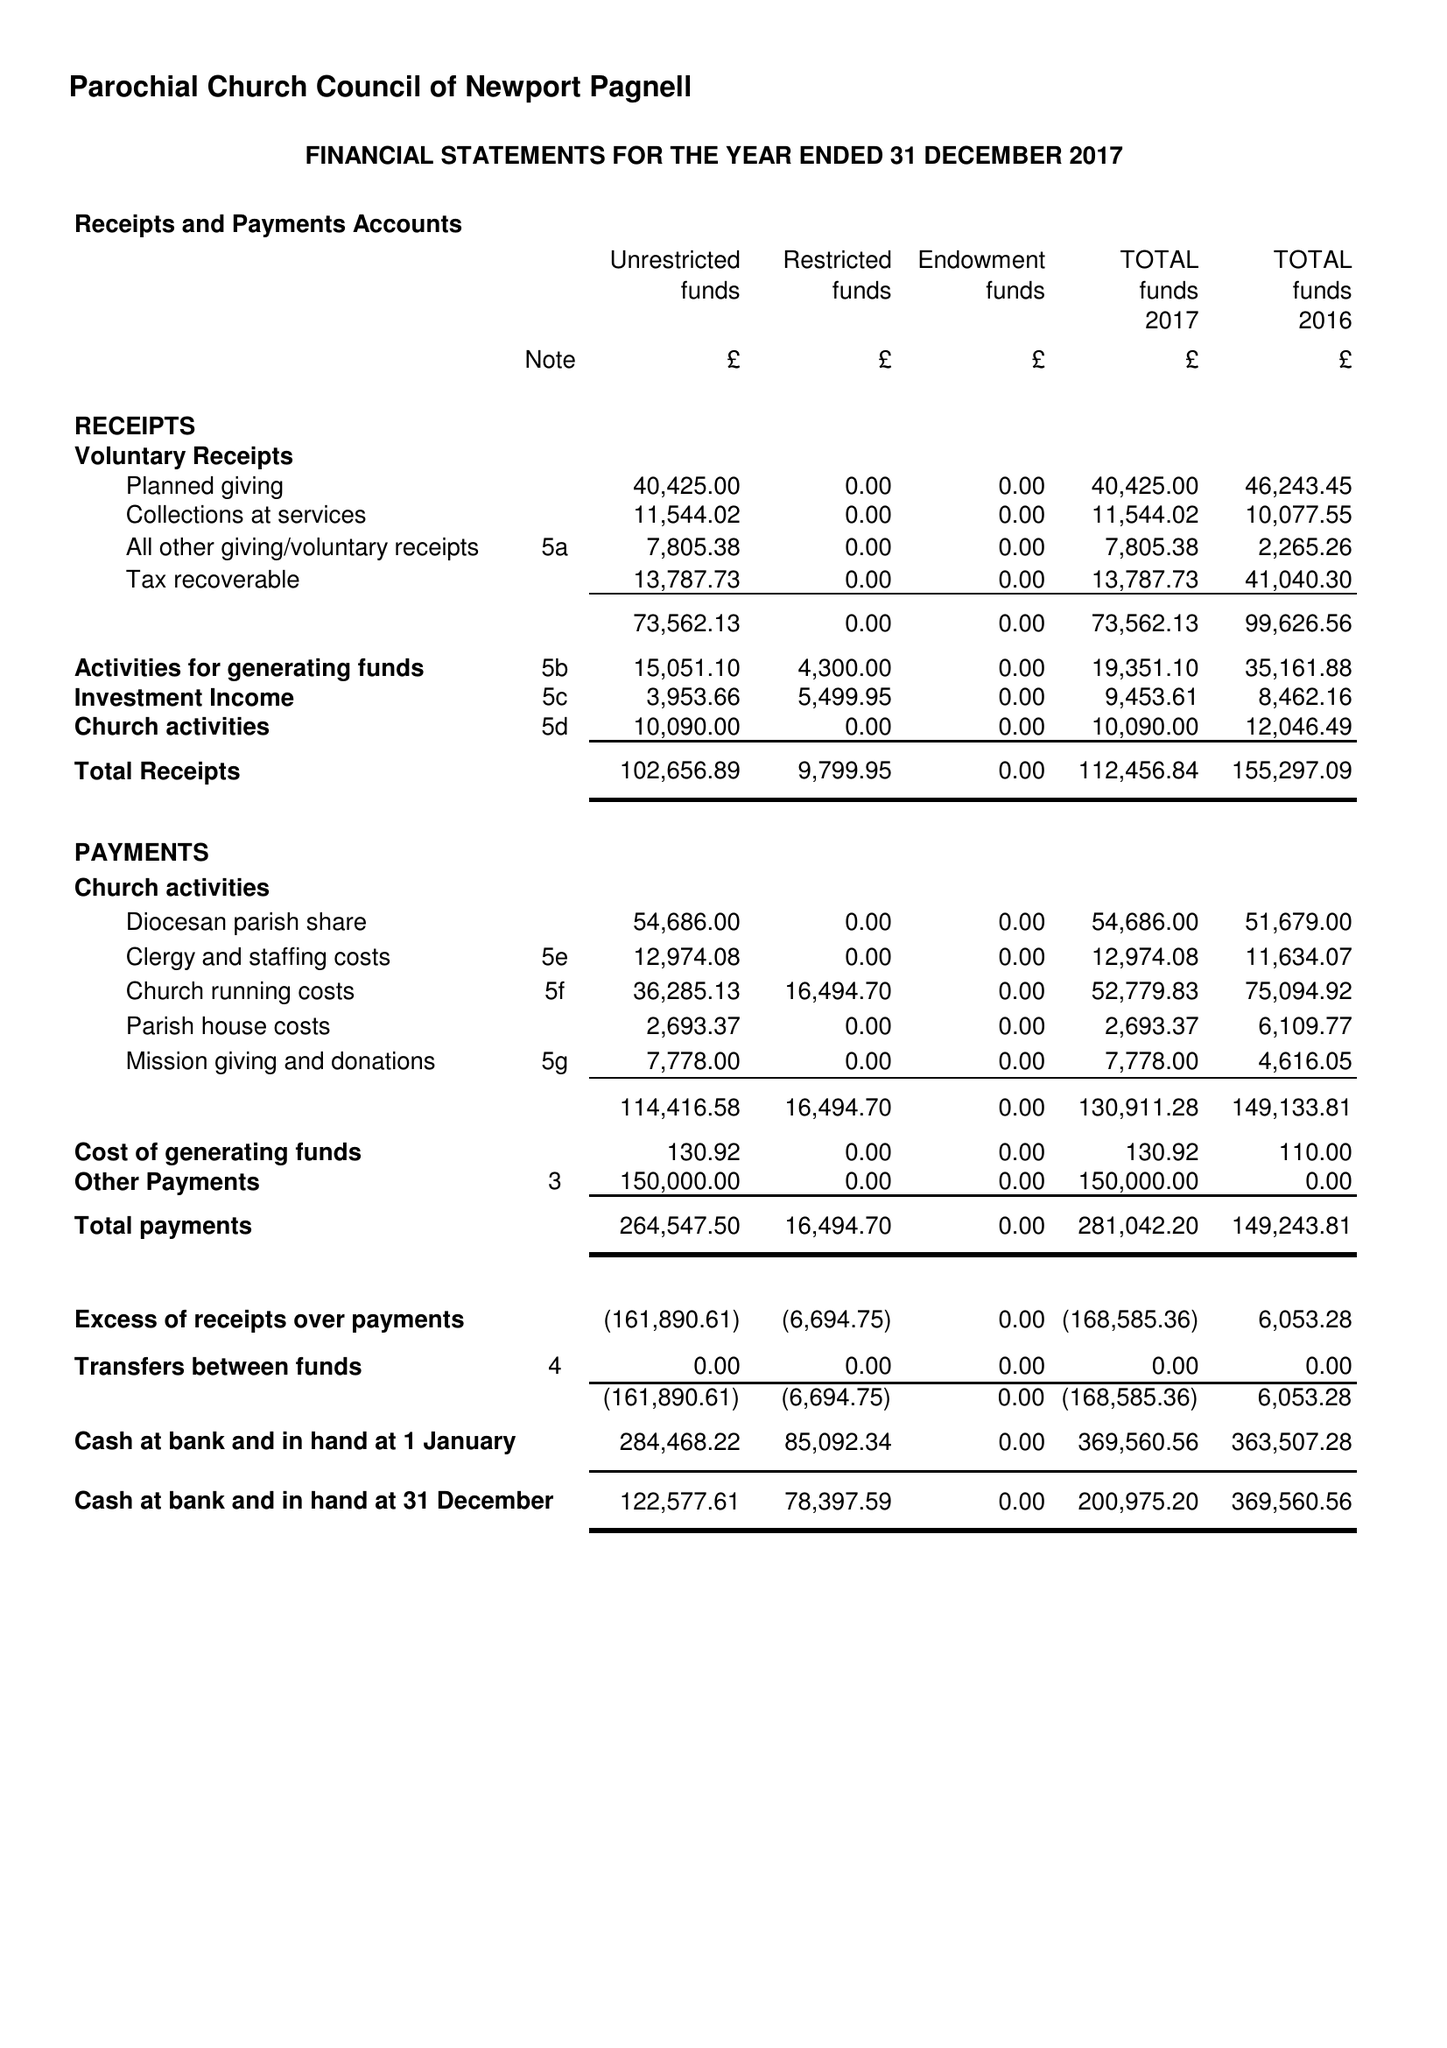What is the value for the address__postcode?
Answer the question using a single word or phrase. MK16 8AR 